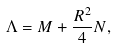Convert formula to latex. <formula><loc_0><loc_0><loc_500><loc_500>\Lambda = M + \frac { R ^ { 2 } } { 4 } N ,</formula> 